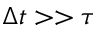Convert formula to latex. <formula><loc_0><loc_0><loc_500><loc_500>\Delta t > > \tau</formula> 